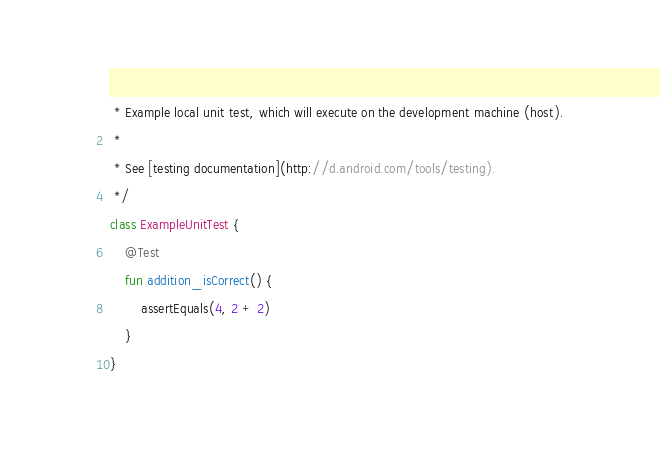Convert code to text. <code><loc_0><loc_0><loc_500><loc_500><_Kotlin_> * Example local unit test, which will execute on the development machine (host).
 *
 * See [testing documentation](http://d.android.com/tools/testing).
 */
class ExampleUnitTest {
    @Test
    fun addition_isCorrect() {
        assertEquals(4, 2 + 2)
    }
}
</code> 